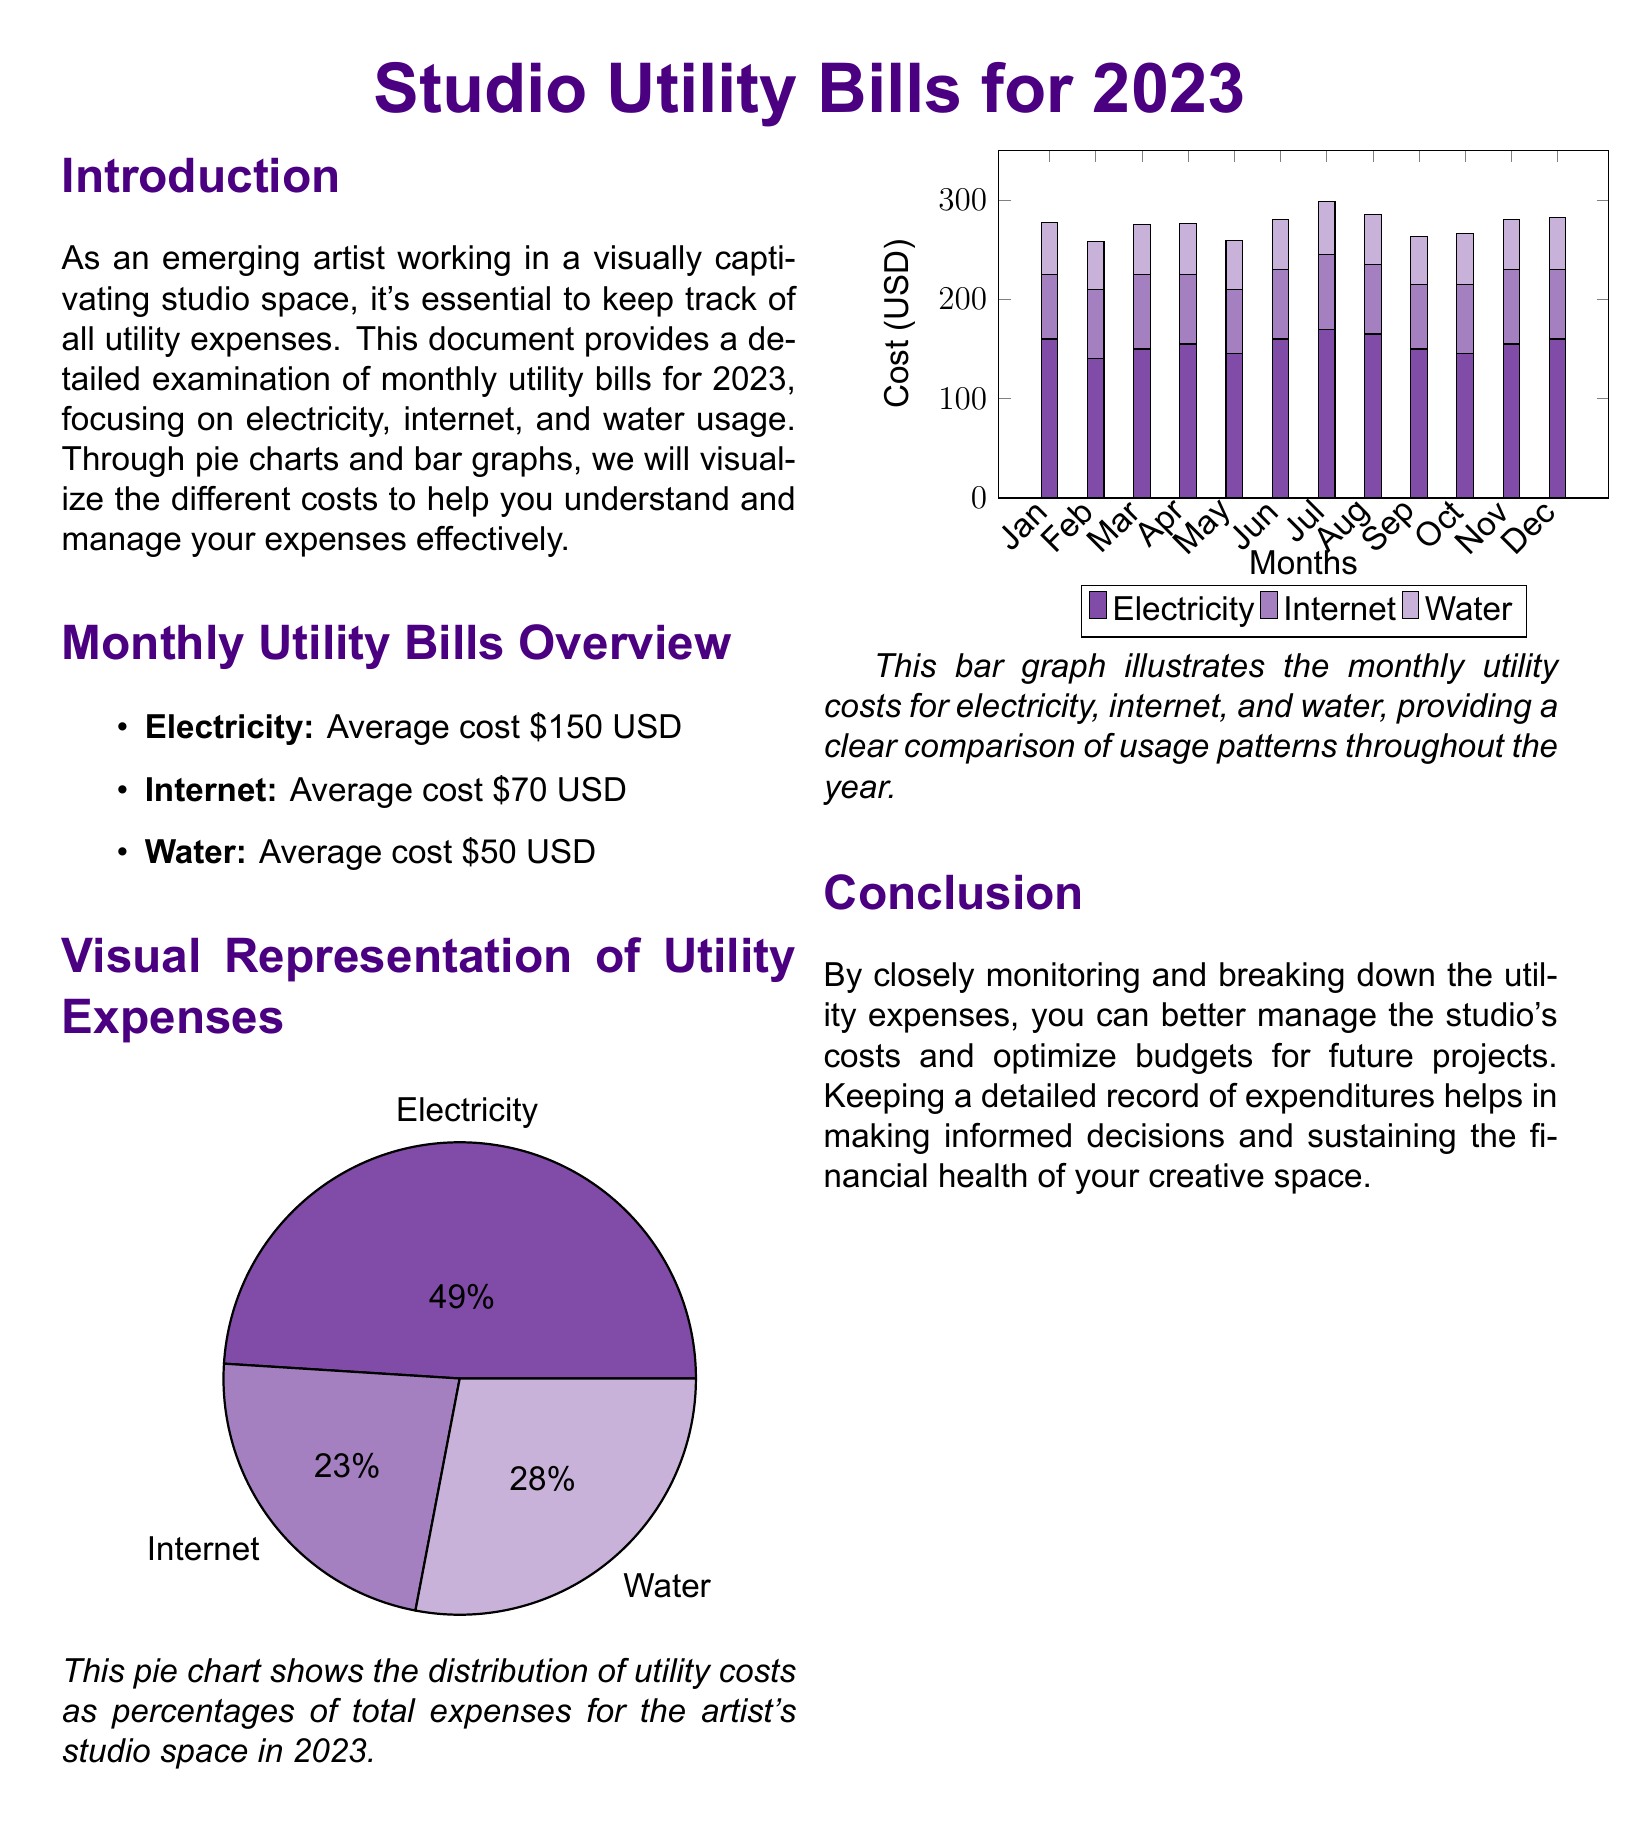What is the average electricity cost? The document states that the average cost for electricity is $150 USD.
Answer: $150 USD What is the primary color used in the document? The primary color defined in the document is RGB (75,0,130).
Answer: RGB (75,0,130) Which month had the highest water cost? By examining the bar graph for water costs, July had the highest cost at $53 USD.
Answer: July What does the pie chart represent? The pie chart shows the distribution of utility costs as percentages of total expenses for the artist's studio space in 2023.
Answer: Distribution of utility costs How many months were analyzed in the report? The report covers the utility bills for the entire year of 2023, which is 12 months.
Answer: 12 months What is the total average cost of all utilities combined? The total average cost is calculated as $150 + $70 + $50, which equals $270 USD.
Answer: $270 USD What is the purpose of this document? The document aims to provide an examination of monthly utility bills for effective expense management.
Answer: Expense management What type of visual representations are used in this document? The document employs pie charts and bar graphs to visualize the utility expenses.
Answer: Pie charts and bar graphs 